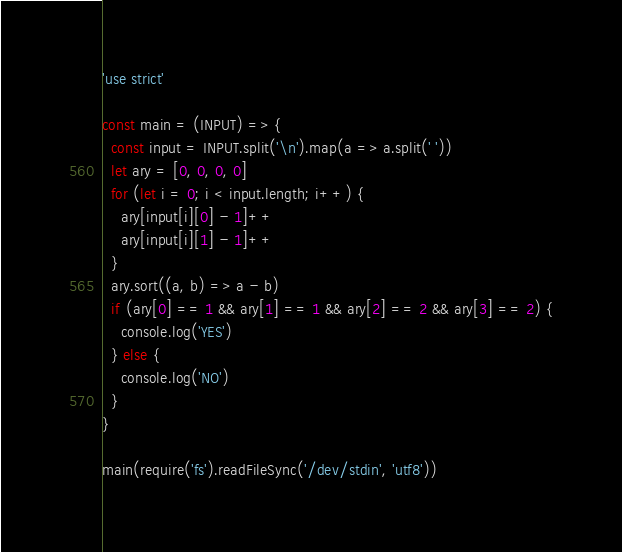<code> <loc_0><loc_0><loc_500><loc_500><_JavaScript_>'use strict'

const main = (INPUT) => {
  const input = INPUT.split('\n').map(a => a.split(' '))
  let ary = [0, 0, 0, 0]
  for (let i = 0; i < input.length; i++) {
    ary[input[i][0] - 1]++
    ary[input[i][1] - 1]++
  }
  ary.sort((a, b) => a - b)
  if (ary[0] == 1 && ary[1] == 1 && ary[2] == 2 && ary[3] == 2) {
    console.log('YES')
  } else {
    console.log('NO')
  }
}

main(require('fs').readFileSync('/dev/stdin', 'utf8'))
</code> 